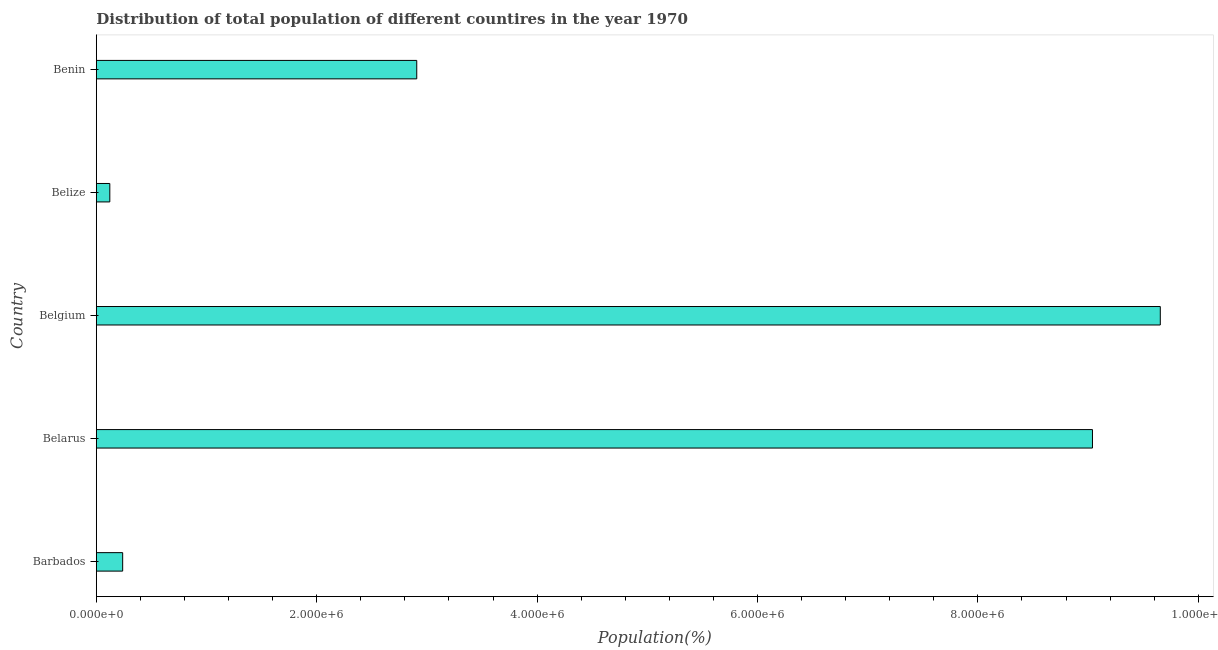Does the graph contain grids?
Make the answer very short. No. What is the title of the graph?
Your answer should be very brief. Distribution of total population of different countires in the year 1970. What is the label or title of the X-axis?
Ensure brevity in your answer.  Population(%). What is the label or title of the Y-axis?
Make the answer very short. Country. What is the population in Belarus?
Provide a short and direct response. 9.04e+06. Across all countries, what is the maximum population?
Your answer should be very brief. 9.66e+06. Across all countries, what is the minimum population?
Your response must be concise. 1.22e+05. In which country was the population minimum?
Offer a very short reply. Belize. What is the sum of the population?
Your answer should be compact. 2.20e+07. What is the difference between the population in Belarus and Belize?
Provide a succinct answer. 8.92e+06. What is the average population per country?
Ensure brevity in your answer.  4.39e+06. What is the median population?
Ensure brevity in your answer.  2.91e+06. In how many countries, is the population greater than 400000 %?
Offer a very short reply. 3. What is the ratio of the population in Belarus to that in Belize?
Ensure brevity in your answer.  73.99. Is the difference between the population in Barbados and Belize greater than the difference between any two countries?
Your response must be concise. No. What is the difference between the highest and the second highest population?
Make the answer very short. 6.16e+05. What is the difference between the highest and the lowest population?
Your answer should be compact. 9.53e+06. In how many countries, is the population greater than the average population taken over all countries?
Offer a very short reply. 2. How many bars are there?
Provide a succinct answer. 5. Are all the bars in the graph horizontal?
Give a very brief answer. Yes. How many countries are there in the graph?
Offer a very short reply. 5. Are the values on the major ticks of X-axis written in scientific E-notation?
Your answer should be compact. Yes. What is the Population(%) in Barbados?
Your answer should be very brief. 2.39e+05. What is the Population(%) in Belarus?
Offer a very short reply. 9.04e+06. What is the Population(%) of Belgium?
Your answer should be very brief. 9.66e+06. What is the Population(%) of Belize?
Provide a succinct answer. 1.22e+05. What is the Population(%) of Benin?
Offer a very short reply. 2.91e+06. What is the difference between the Population(%) in Barbados and Belarus?
Give a very brief answer. -8.80e+06. What is the difference between the Population(%) in Barbados and Belgium?
Ensure brevity in your answer.  -9.42e+06. What is the difference between the Population(%) in Barbados and Belize?
Your answer should be very brief. 1.17e+05. What is the difference between the Population(%) in Barbados and Benin?
Make the answer very short. -2.67e+06. What is the difference between the Population(%) in Belarus and Belgium?
Offer a very short reply. -6.16e+05. What is the difference between the Population(%) in Belarus and Belize?
Your response must be concise. 8.92e+06. What is the difference between the Population(%) in Belarus and Benin?
Offer a very short reply. 6.13e+06. What is the difference between the Population(%) in Belgium and Belize?
Make the answer very short. 9.53e+06. What is the difference between the Population(%) in Belgium and Benin?
Offer a very short reply. 6.75e+06. What is the difference between the Population(%) in Belize and Benin?
Provide a succinct answer. -2.79e+06. What is the ratio of the Population(%) in Barbados to that in Belarus?
Make the answer very short. 0.03. What is the ratio of the Population(%) in Barbados to that in Belgium?
Provide a short and direct response. 0.03. What is the ratio of the Population(%) in Barbados to that in Belize?
Make the answer very short. 1.96. What is the ratio of the Population(%) in Barbados to that in Benin?
Your response must be concise. 0.08. What is the ratio of the Population(%) in Belarus to that in Belgium?
Give a very brief answer. 0.94. What is the ratio of the Population(%) in Belarus to that in Belize?
Offer a very short reply. 73.99. What is the ratio of the Population(%) in Belarus to that in Benin?
Your response must be concise. 3.11. What is the ratio of the Population(%) in Belgium to that in Belize?
Provide a succinct answer. 79.03. What is the ratio of the Population(%) in Belgium to that in Benin?
Provide a short and direct response. 3.32. What is the ratio of the Population(%) in Belize to that in Benin?
Your answer should be compact. 0.04. 